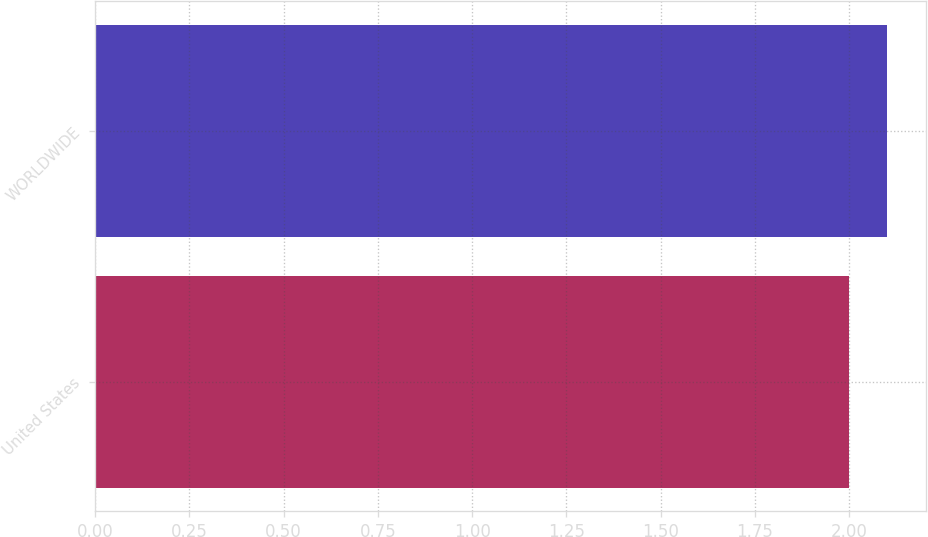<chart> <loc_0><loc_0><loc_500><loc_500><bar_chart><fcel>United States<fcel>WORLDWIDE<nl><fcel>2<fcel>2.1<nl></chart> 